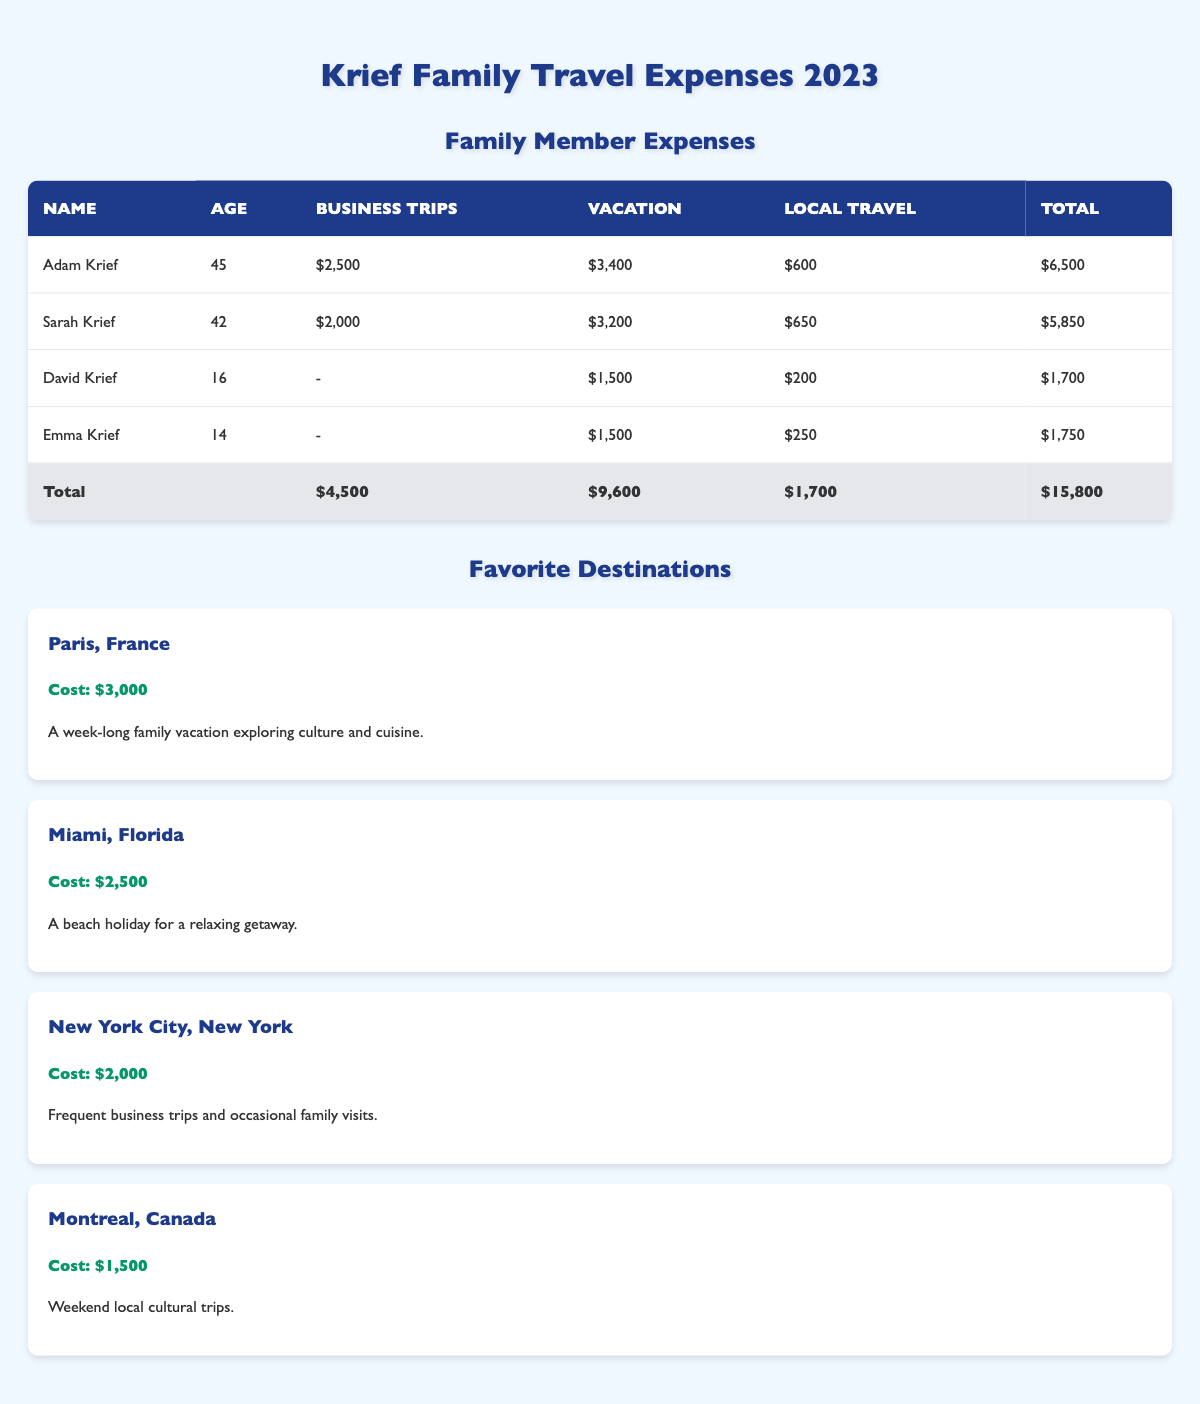What are the total travel expenses for the Krief family in 2023? The total travel expenses are presented in the table's total row, where it clearly states that the grand total is $15,800.
Answer: $15,800 How much did Adam Krief spend on local travel? The table shows that Adam Krief's local travel expenses are listed as $600.
Answer: $600 Who spent the least on vacation travel? By comparing the vacation expenses in the table, both David and Emma Krief spent $1,500, which are the lowest amounts.
Answer: David and Emma Krief What is the combined total of vacation expenses for Sarah and Adam Krief? Sarah's vacation expenses are $3,200 and Adam's are $3,400. Adding these gives $3,200 + $3,400 = $6,600.
Answer: $6,600 Did David Krief incur any business trip expenses? The table indicates that David did not have any business trip expenses listed, as his cell for business trips shows a dash (-).
Answer: No Which family member had the highest total travel expenses? A look at the total expenses for each family member shows Adam Krief with $6,500 as the highest total.
Answer: Adam Krief What is the average amount spent on vacation by all family members? The family members with vacation expenses are Adam, Sarah, David, and Emma. Adding their expenses gives $3,400 + $3,200 + $1,500 + $1,500 = $11,600. Dividing by 4 family members leads to an average of $11,600 / 4 = $2,900.
Answer: $2,900 Which destination had the lowest cost for the Krief family's travel in 2023? The favorite destinations' costs are $3,000 for Paris, $2,500 for Miami, $2,000 for New York, and $1,500 for Montreal. Therefore, Montreal has the lowest cost at $1,500.
Answer: Montreal, Canada What was the total local travel expense for the entire Krief family? The table indicates local travel expenses for Adam ($600), Sarah ($650), David ($200), and Emma ($250). Summing these gives $600 + $650 + $200 + $250 = $1,700.
Answer: $1,700 Is it true that the total business trip expenses are equal to the business trip expenses of Adam and Sarah combined? The table lists total business trip expenses as $4,500, while adding Adam's ($2,500) and Sarah's ($2,000) gives $2,500 + $2,000 = $4,500, confirming the statement is true.
Answer: Yes 